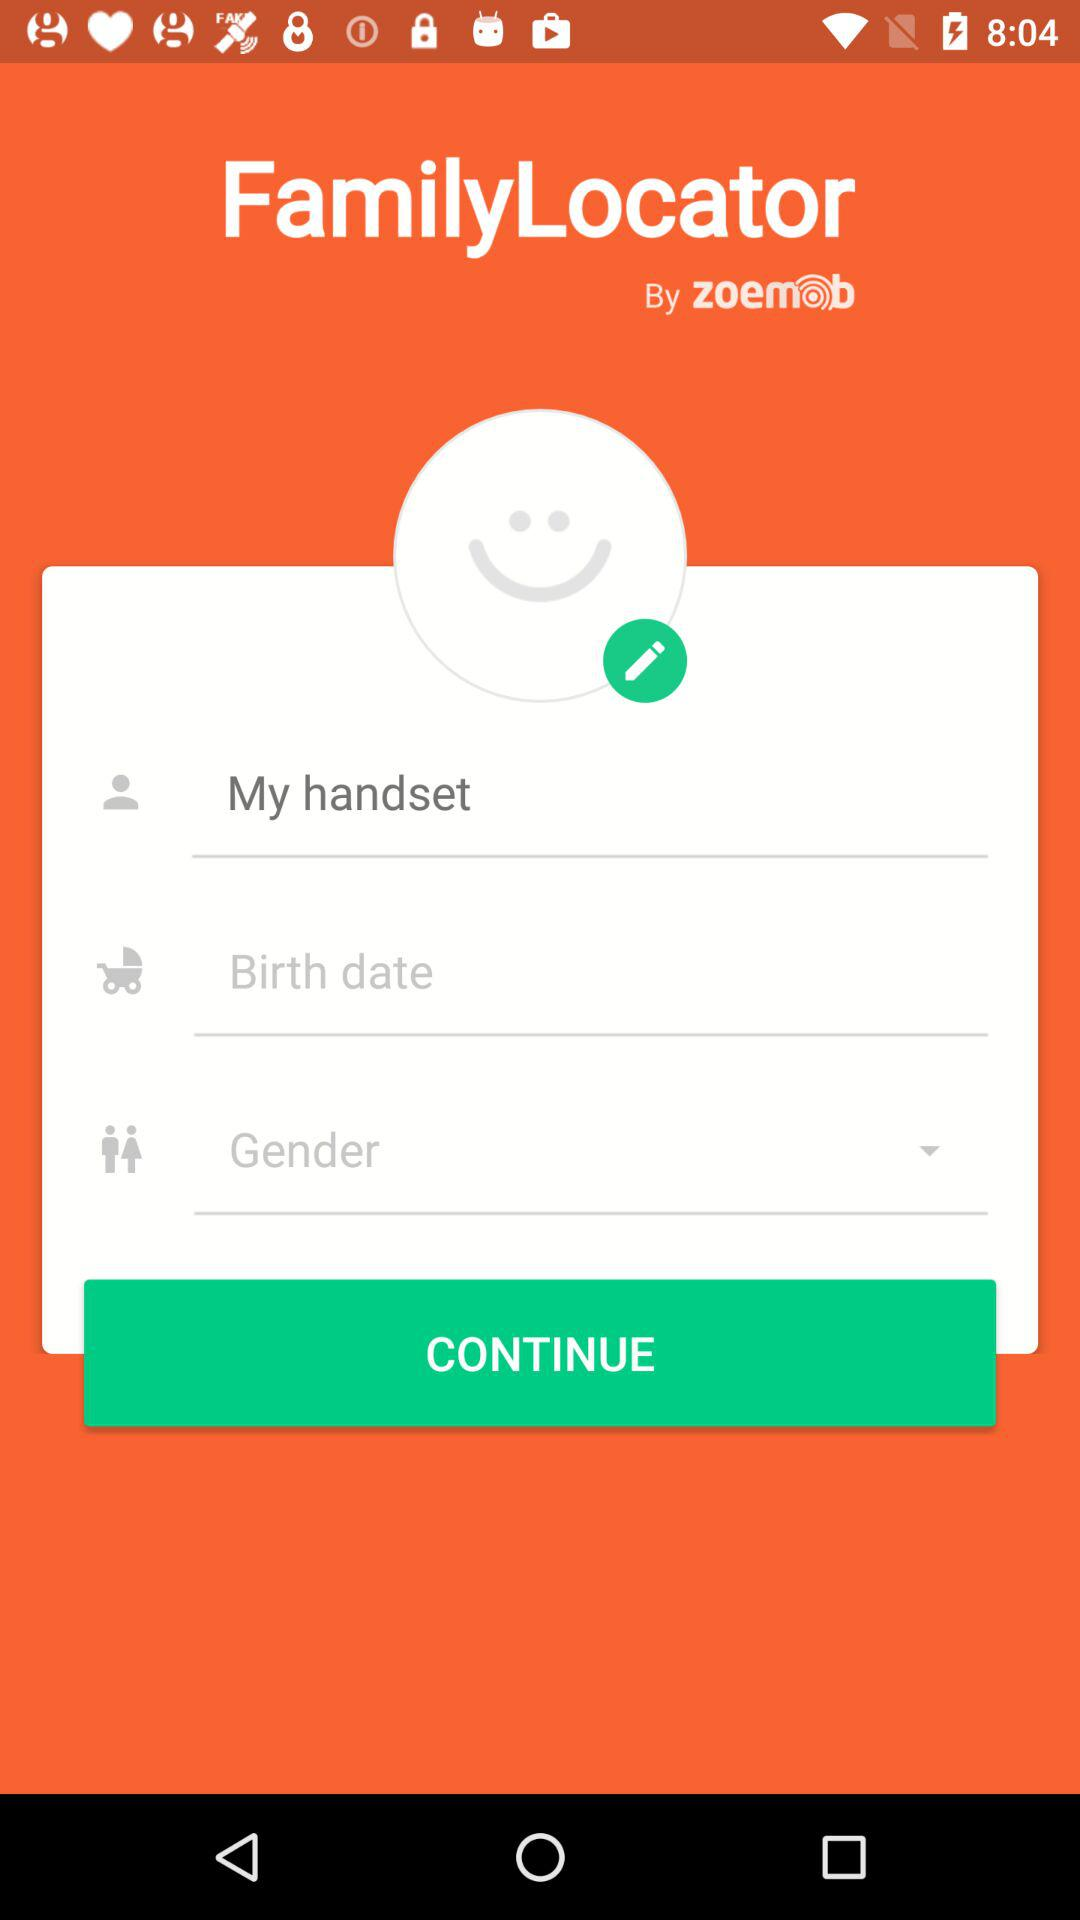What is the name mentioned in the name textbox? The name is "My handset". 